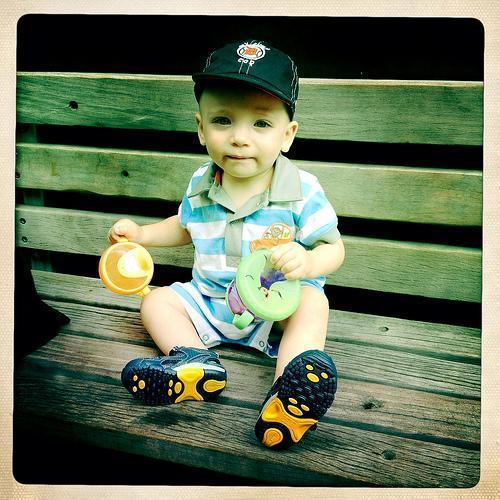How many cups does the little boy have?
Give a very brief answer. 1. How many children are in the photo?
Give a very brief answer. 1. How many people are pictured?
Give a very brief answer. 1. 